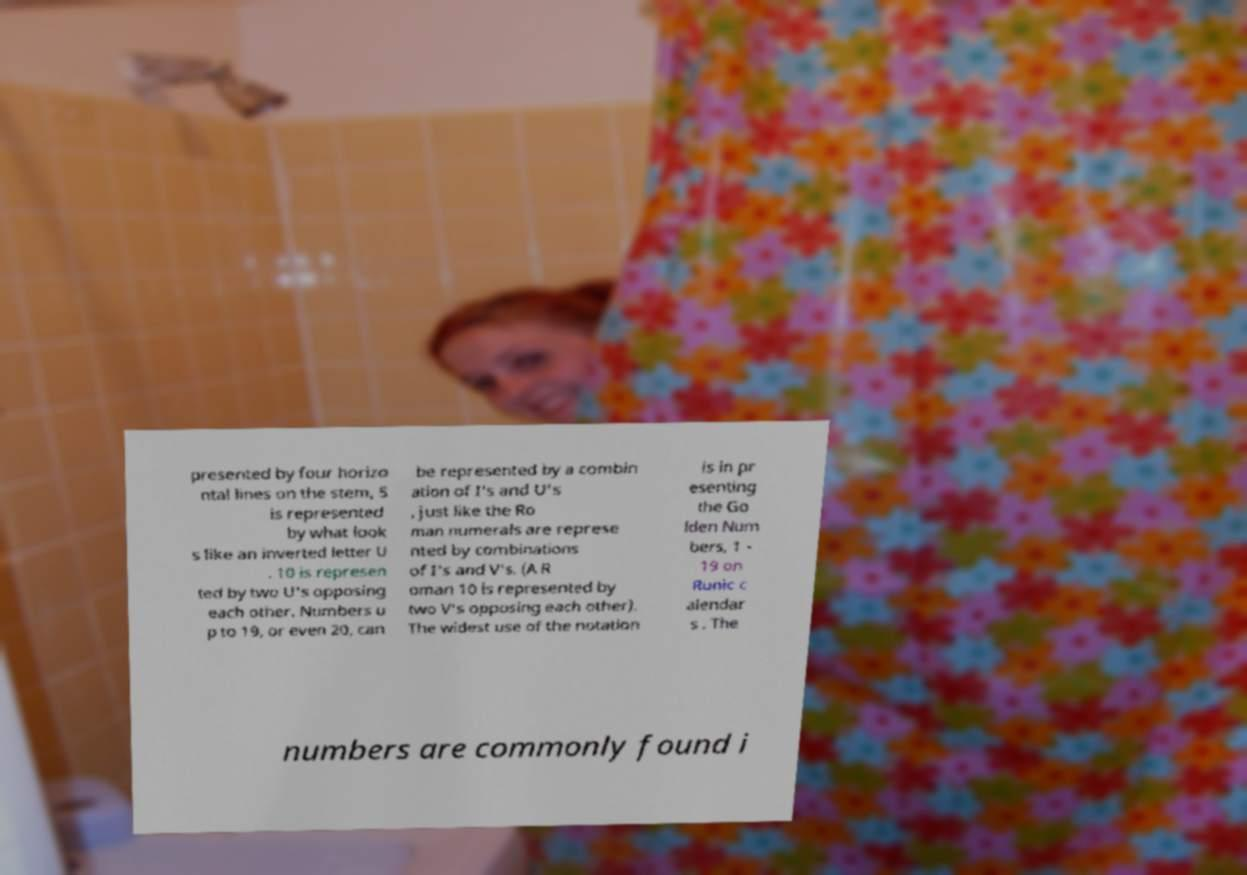I need the written content from this picture converted into text. Can you do that? presented by four horizo ntal lines on the stem, 5 is represented by what look s like an inverted letter U . 10 is represen ted by two U's opposing each other. Numbers u p to 19, or even 20, can be represented by a combin ation of I's and U's , just like the Ro man numerals are represe nted by combinations of I's and V's. (A R oman 10 is represented by two V's opposing each other). The widest use of the notation is in pr esenting the Go lden Num bers, 1 - 19 on Runic c alendar s . The numbers are commonly found i 